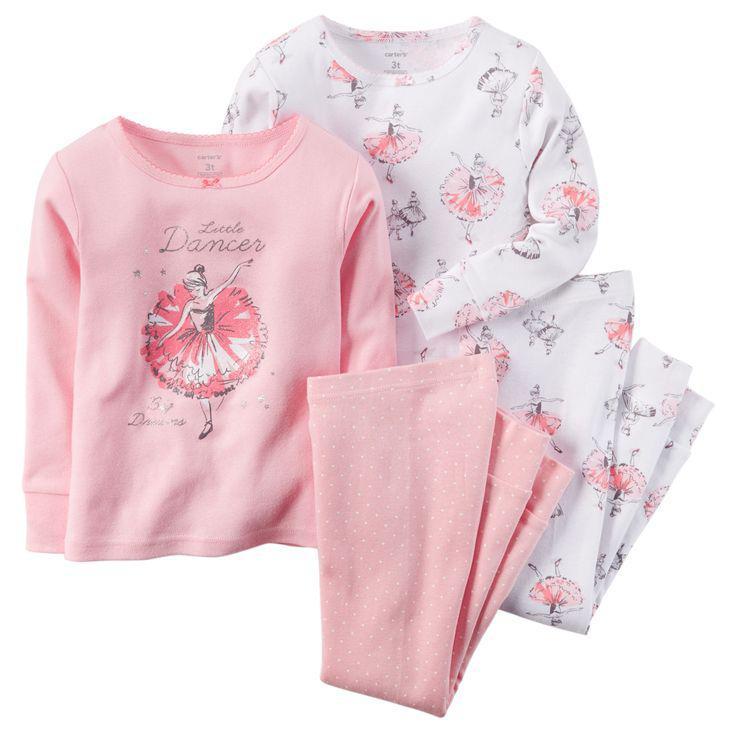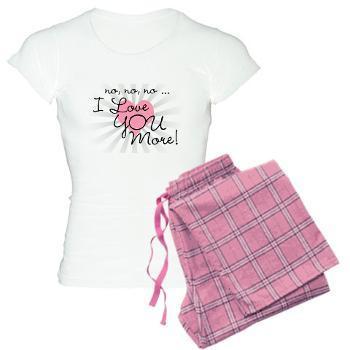The first image is the image on the left, the second image is the image on the right. Examine the images to the left and right. Is the description "There are two outfits in one of the images." accurate? Answer yes or no. Yes. The first image is the image on the left, the second image is the image on the right. For the images displayed, is the sentence "Sleepwear on the right features a Disney Princess theme on the front." factually correct? Answer yes or no. No. 